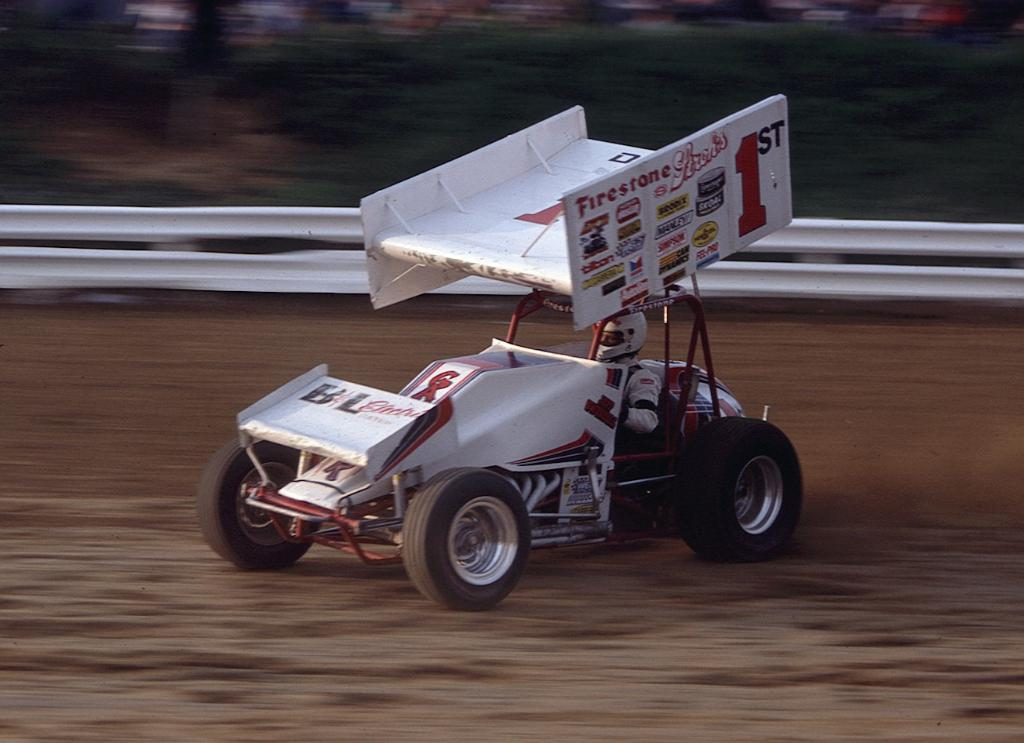<image>
Present a compact description of the photo's key features. A white race car with a few stickers including a Firestone one. 